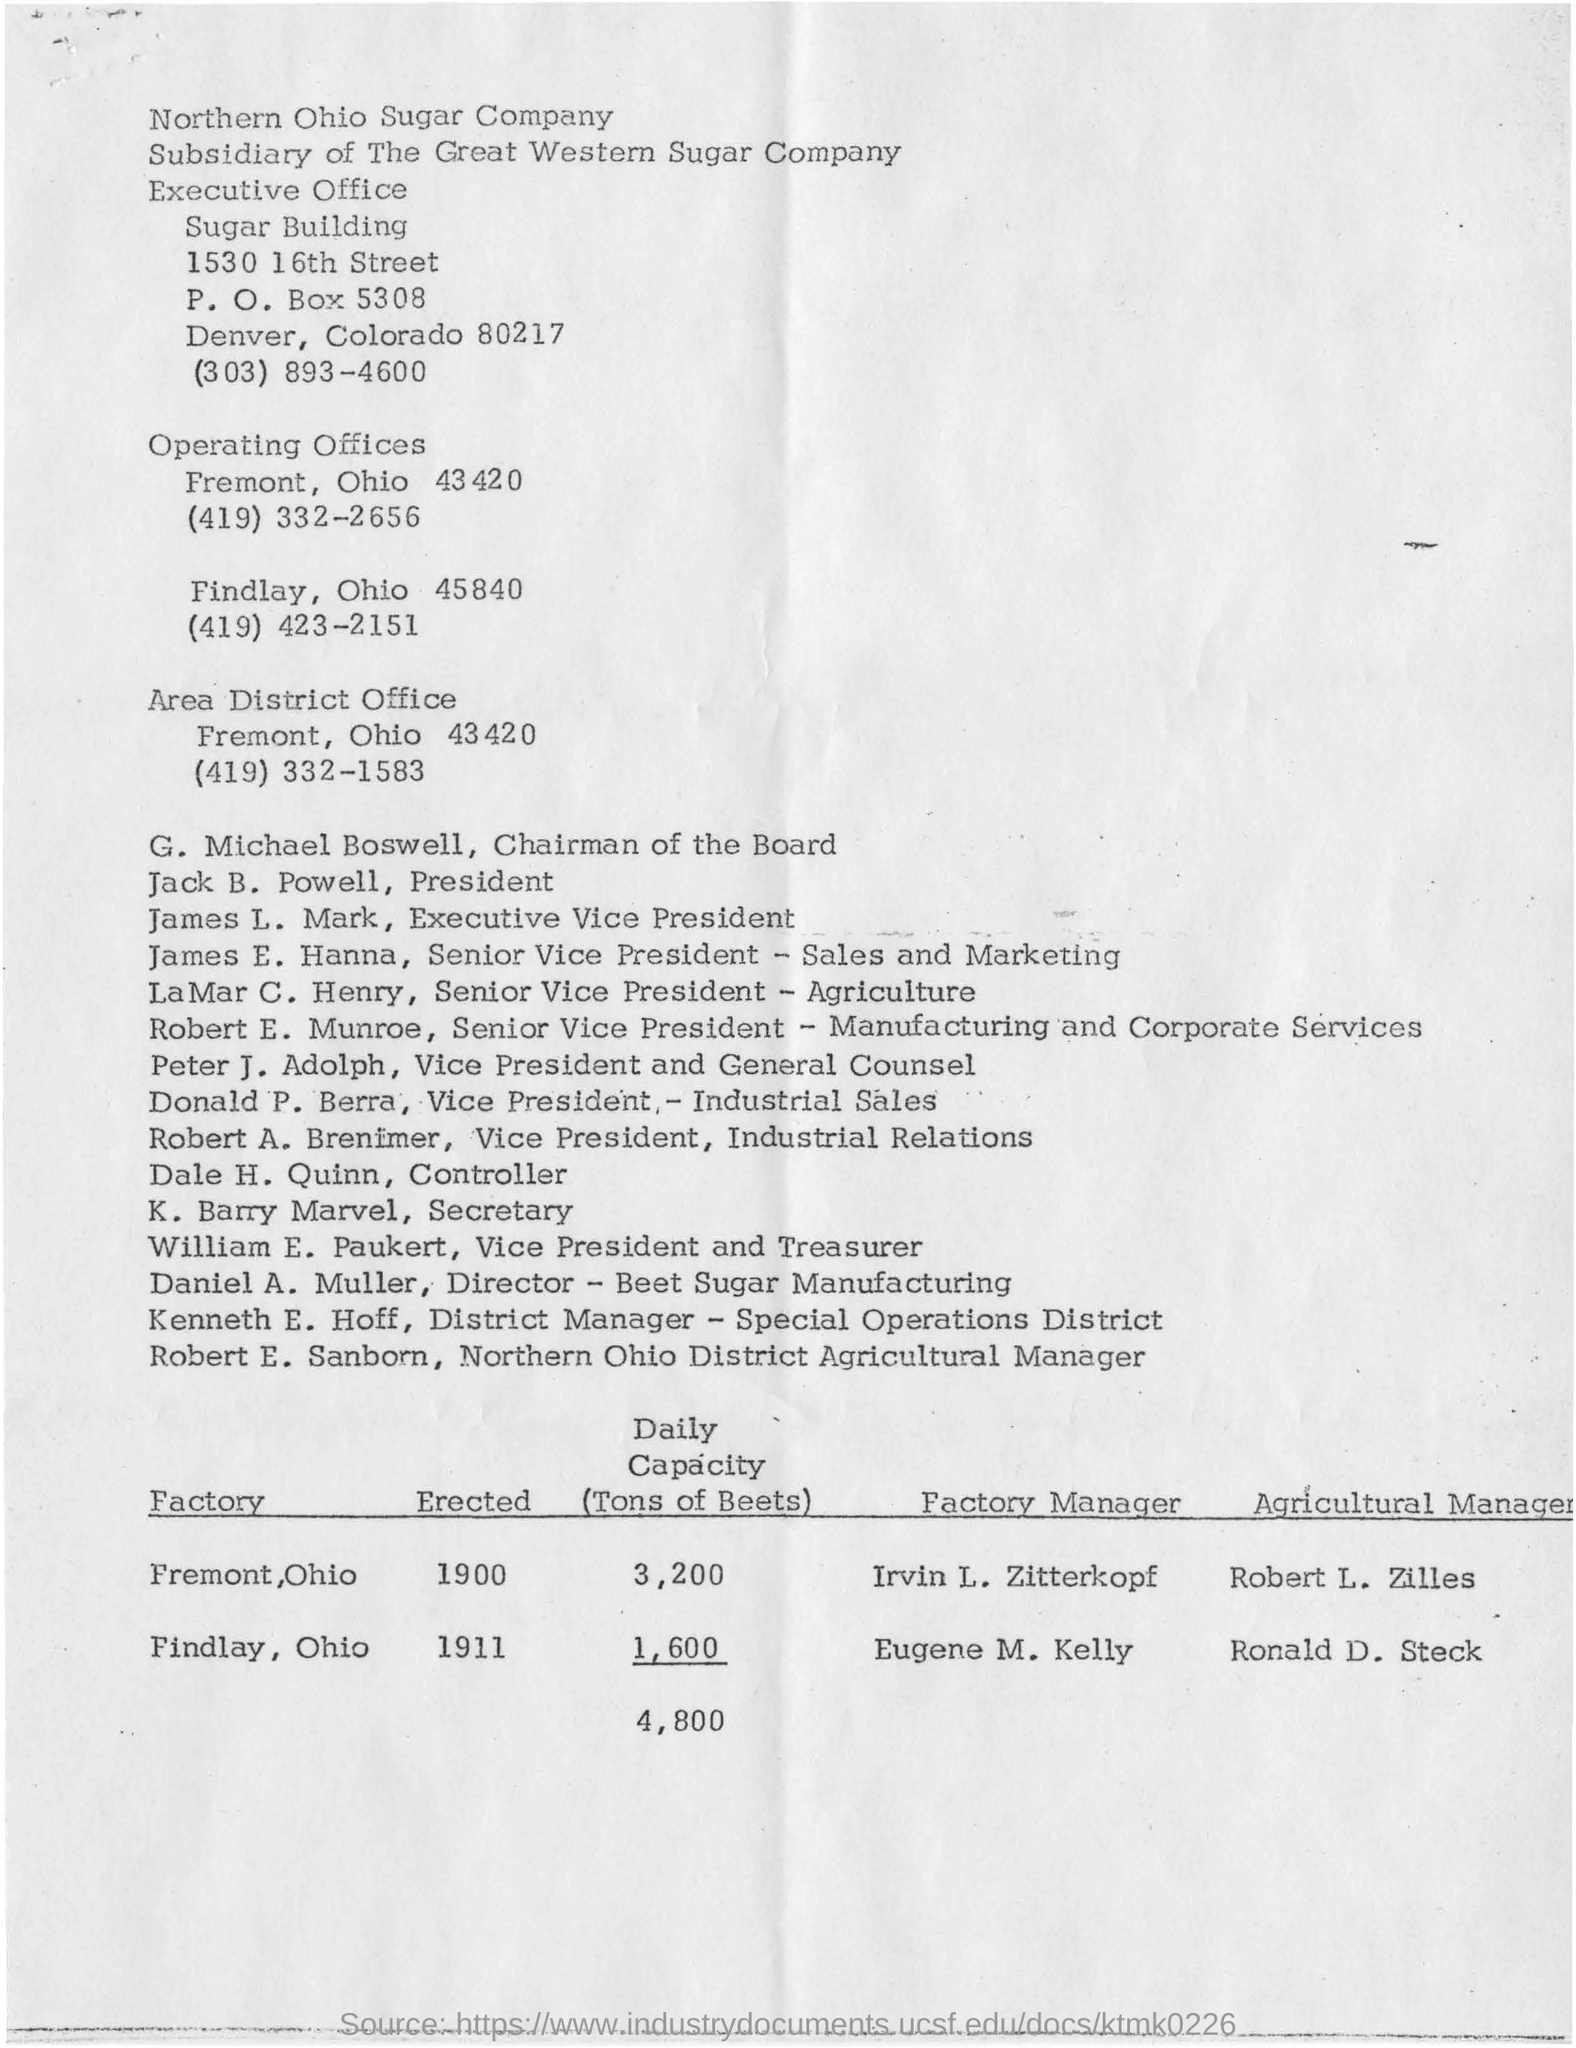What can you infer about beet sugar manufacturing from the factory information provided? Based on the factory information in the image, the company had two factories located in Fremont and Findlay, Ohio. These factories were erected in 1900 and 1911, respectively, with a combined daily capacity of 4,800 tons of beets. This suggests that beet sugar manufacturing was likely a significant part of the company's operations. The named factory and agricultural managers point to a structured operation, indicating that beet sugar manufacturing was a well-established industry at the time. 